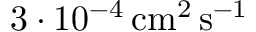Convert formula to latex. <formula><loc_0><loc_0><loc_500><loc_500>3 \cdot 1 0 ^ { - 4 } \, c m ^ { 2 } \, s ^ { - 1 }</formula> 